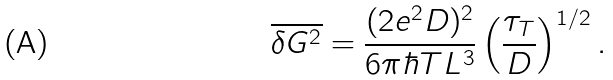Convert formula to latex. <formula><loc_0><loc_0><loc_500><loc_500>\overline { \delta G ^ { 2 } } = \frac { ( 2 e ^ { 2 } D ) ^ { 2 } } { 6 \pi \hbar { T } L ^ { 3 } } \left ( \frac { \tau _ { T } } { D } \right ) ^ { 1 / 2 } .</formula> 